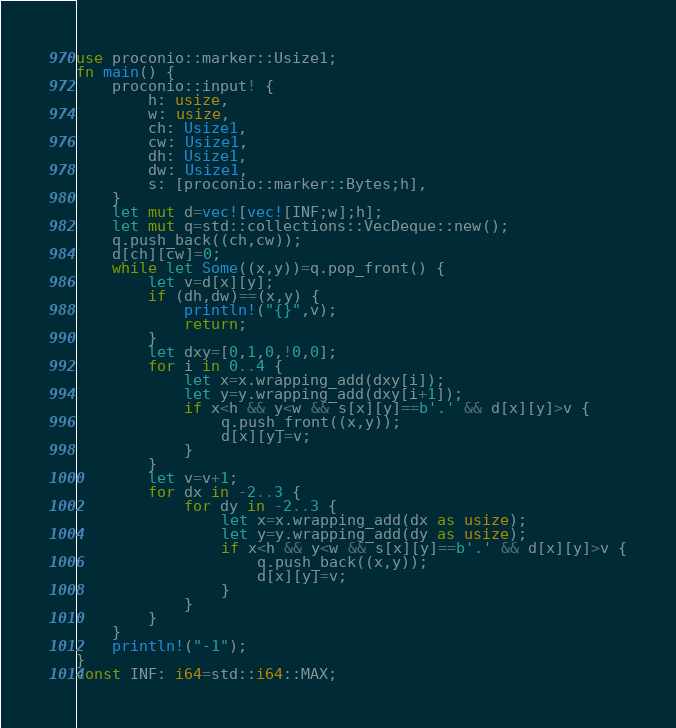<code> <loc_0><loc_0><loc_500><loc_500><_Rust_>use proconio::marker::Usize1;
fn main() {
    proconio::input! {
        h: usize,
        w: usize,
        ch: Usize1,
        cw: Usize1,
        dh: Usize1,
        dw: Usize1,
        s: [proconio::marker::Bytes;h],
    }
    let mut d=vec![vec![INF;w];h];
    let mut q=std::collections::VecDeque::new();
    q.push_back((ch,cw));
    d[ch][cw]=0;
    while let Some((x,y))=q.pop_front() {
        let v=d[x][y];
        if (dh,dw)==(x,y) {
            println!("{}",v);
            return;
        }
        let dxy=[0,1,0,!0,0];
        for i in 0..4 {
            let x=x.wrapping_add(dxy[i]);
            let y=y.wrapping_add(dxy[i+1]);
            if x<h && y<w && s[x][y]==b'.' && d[x][y]>v {
                q.push_front((x,y));
                d[x][y]=v;
            }
        }
        let v=v+1;
        for dx in -2..3 {
            for dy in -2..3 {
                let x=x.wrapping_add(dx as usize);
                let y=y.wrapping_add(dy as usize);
                if x<h && y<w && s[x][y]==b'.' && d[x][y]>v {
                    q.push_back((x,y));
                    d[x][y]=v;
                }
            }
        }
    }
    println!("-1");
}
const INF: i64=std::i64::MAX;</code> 